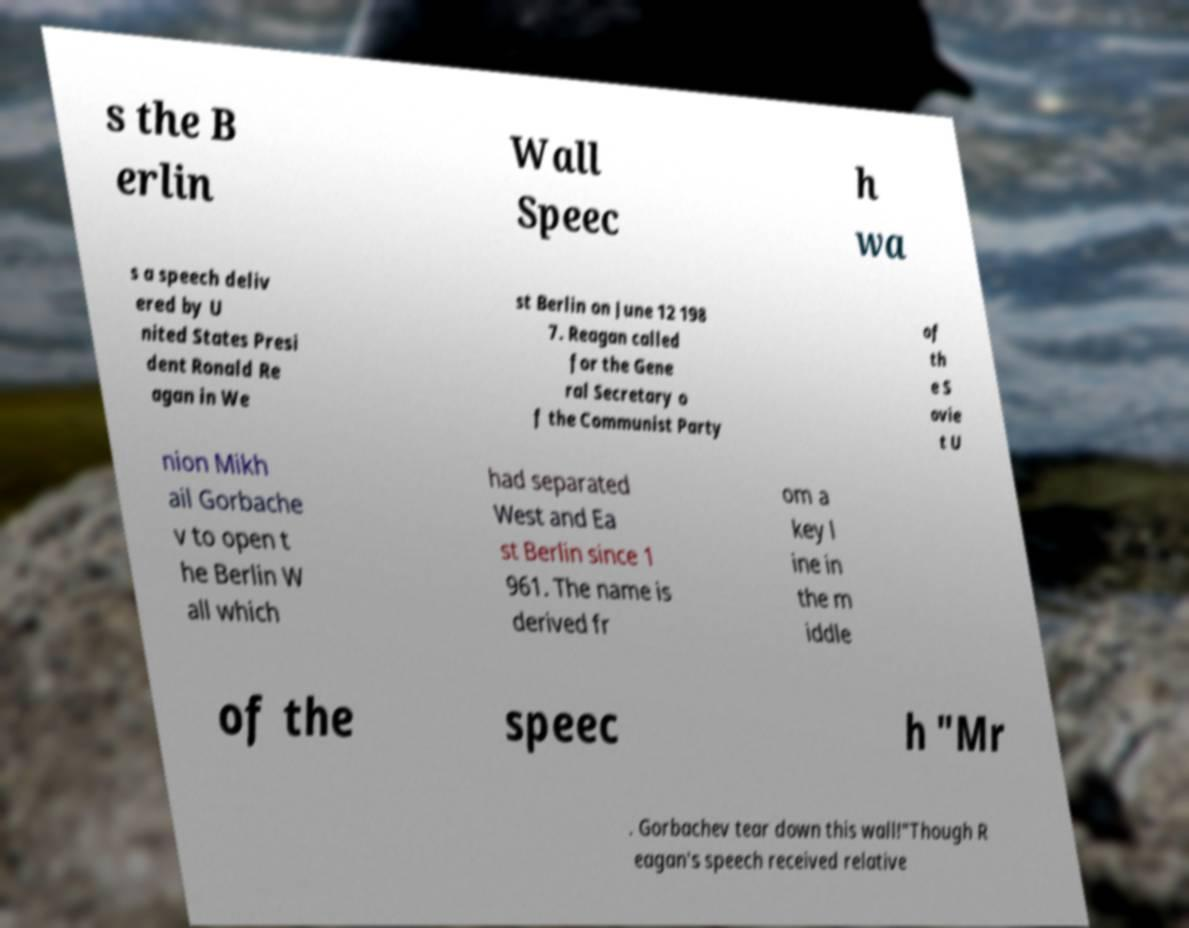For documentation purposes, I need the text within this image transcribed. Could you provide that? s the B erlin Wall Speec h wa s a speech deliv ered by U nited States Presi dent Ronald Re agan in We st Berlin on June 12 198 7. Reagan called for the Gene ral Secretary o f the Communist Party of th e S ovie t U nion Mikh ail Gorbache v to open t he Berlin W all which had separated West and Ea st Berlin since 1 961. The name is derived fr om a key l ine in the m iddle of the speec h "Mr . Gorbachev tear down this wall!"Though R eagan's speech received relative 